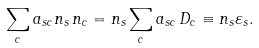Convert formula to latex. <formula><loc_0><loc_0><loc_500><loc_500>\sum _ { c } a _ { s c } n _ { s } \, n _ { c } = n _ { s } \sum _ { c } a _ { s c } \, D _ { c } \equiv n _ { s } \varepsilon _ { s } .</formula> 